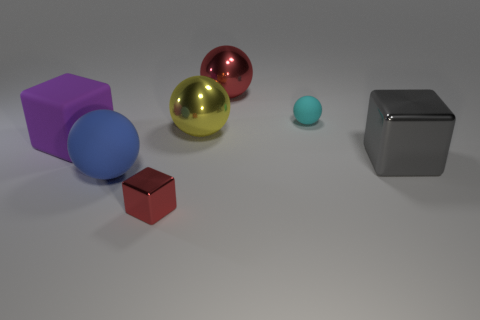The big rubber object that is the same shape as the tiny cyan rubber object is what color?
Offer a very short reply. Blue. What size is the cyan object that is the same shape as the big red object?
Your answer should be compact. Small. What is the material of the big purple cube in front of the small matte object?
Your response must be concise. Rubber. Are there fewer large metallic blocks behind the big gray object than purple things?
Your answer should be compact. Yes. There is a big matte object that is behind the sphere that is left of the small red cube; what shape is it?
Keep it short and to the point. Cube. The big rubber cube is what color?
Keep it short and to the point. Purple. How many other objects are the same size as the gray shiny block?
Ensure brevity in your answer.  4. There is a block that is to the left of the large gray shiny cube and behind the big blue thing; what material is it made of?
Provide a succinct answer. Rubber. There is a metallic object that is behind the yellow shiny ball; does it have the same size as the small metallic thing?
Make the answer very short. No. Is the big rubber ball the same color as the tiny matte object?
Your answer should be compact. No. 